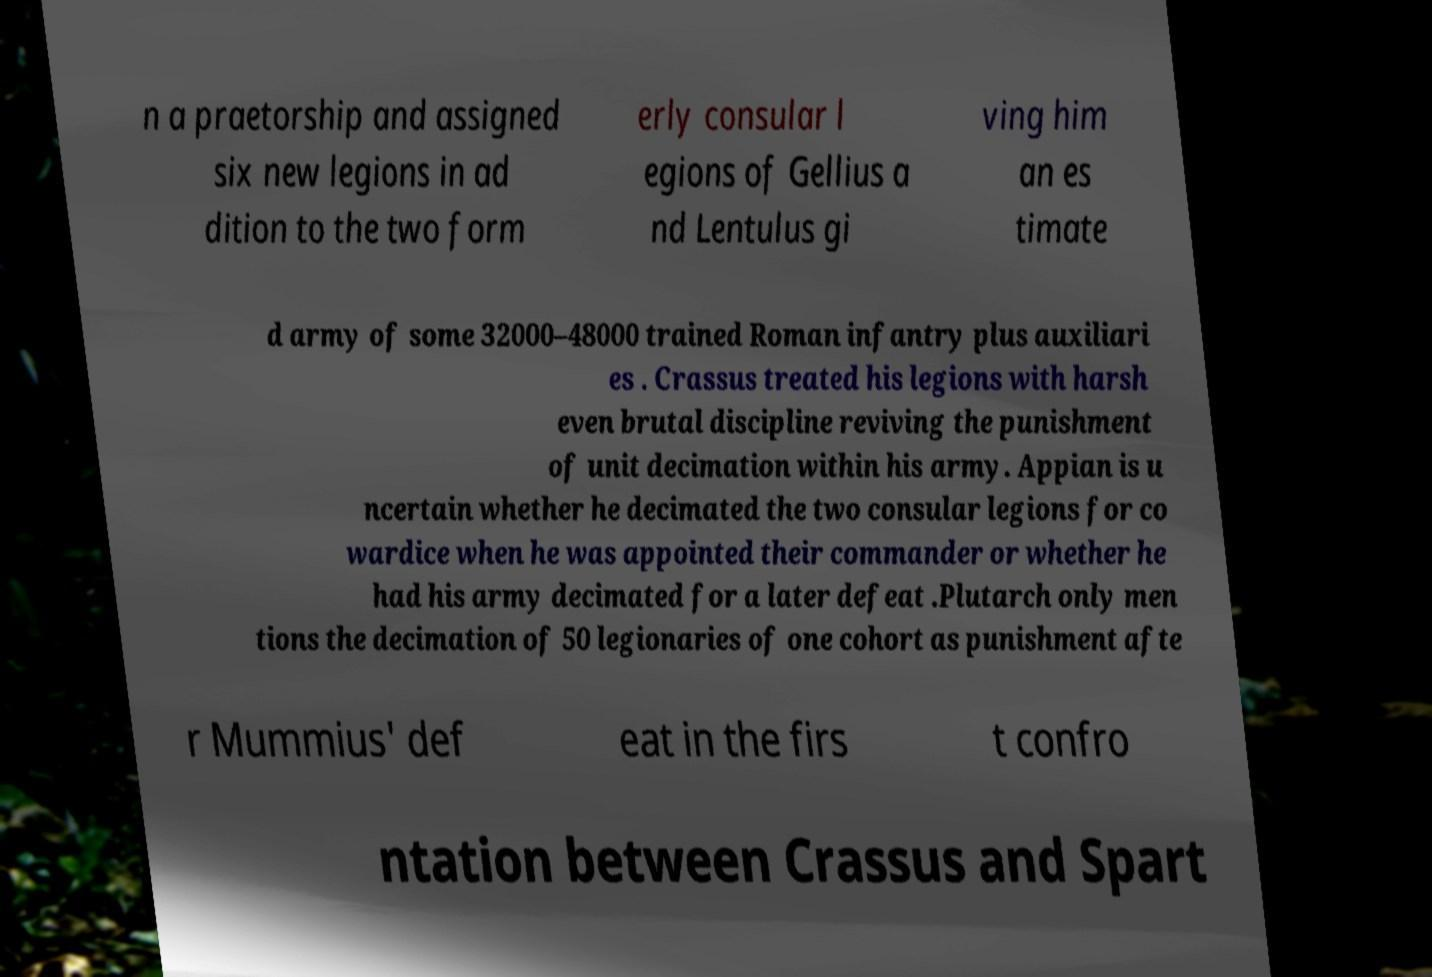I need the written content from this picture converted into text. Can you do that? n a praetorship and assigned six new legions in ad dition to the two form erly consular l egions of Gellius a nd Lentulus gi ving him an es timate d army of some 32000–48000 trained Roman infantry plus auxiliari es . Crassus treated his legions with harsh even brutal discipline reviving the punishment of unit decimation within his army. Appian is u ncertain whether he decimated the two consular legions for co wardice when he was appointed their commander or whether he had his army decimated for a later defeat .Plutarch only men tions the decimation of 50 legionaries of one cohort as punishment afte r Mummius' def eat in the firs t confro ntation between Crassus and Spart 